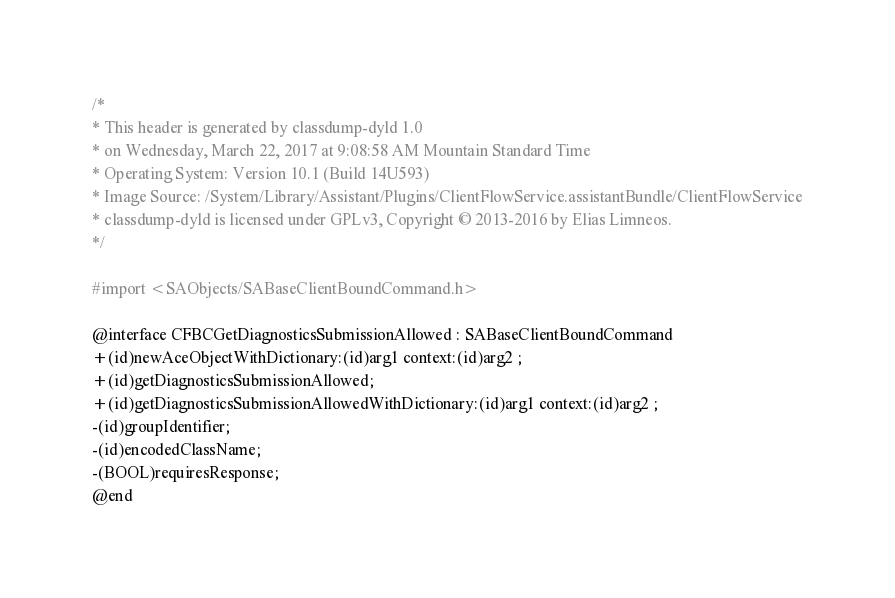Convert code to text. <code><loc_0><loc_0><loc_500><loc_500><_C_>/*
* This header is generated by classdump-dyld 1.0
* on Wednesday, March 22, 2017 at 9:08:58 AM Mountain Standard Time
* Operating System: Version 10.1 (Build 14U593)
* Image Source: /System/Library/Assistant/Plugins/ClientFlowService.assistantBundle/ClientFlowService
* classdump-dyld is licensed under GPLv3, Copyright © 2013-2016 by Elias Limneos.
*/

#import <SAObjects/SABaseClientBoundCommand.h>

@interface CFBCGetDiagnosticsSubmissionAllowed : SABaseClientBoundCommand
+(id)newAceObjectWithDictionary:(id)arg1 context:(id)arg2 ;
+(id)getDiagnosticsSubmissionAllowed;
+(id)getDiagnosticsSubmissionAllowedWithDictionary:(id)arg1 context:(id)arg2 ;
-(id)groupIdentifier;
-(id)encodedClassName;
-(BOOL)requiresResponse;
@end

</code> 